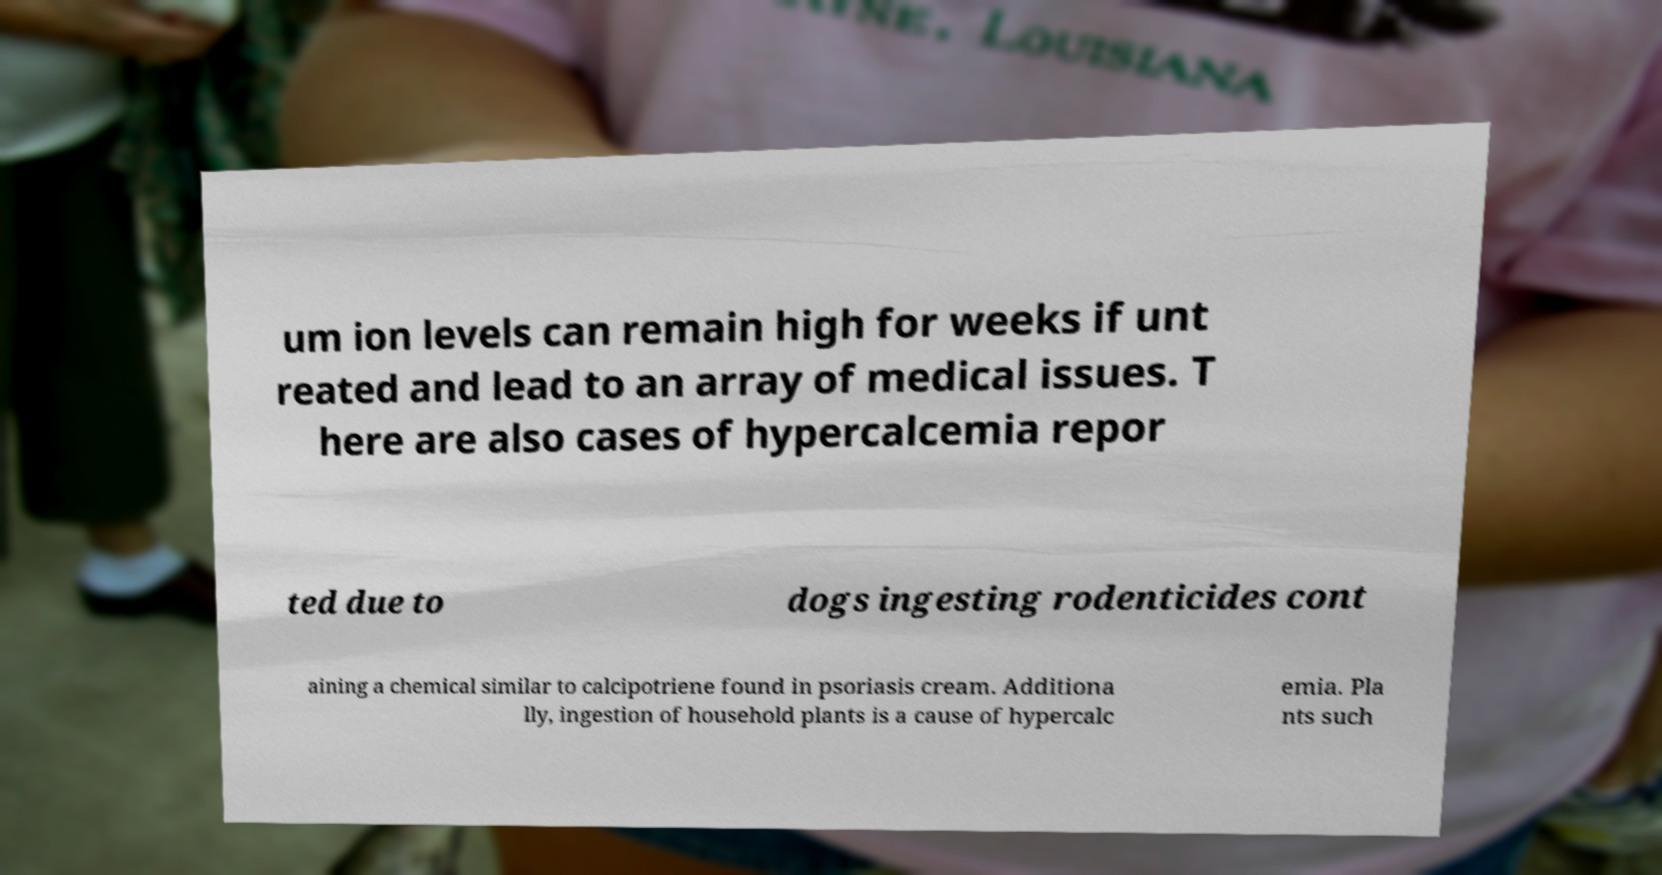Can you read and provide the text displayed in the image?This photo seems to have some interesting text. Can you extract and type it out for me? um ion levels can remain high for weeks if unt reated and lead to an array of medical issues. T here are also cases of hypercalcemia repor ted due to dogs ingesting rodenticides cont aining a chemical similar to calcipotriene found in psoriasis cream. Additiona lly, ingestion of household plants is a cause of hypercalc emia. Pla nts such 